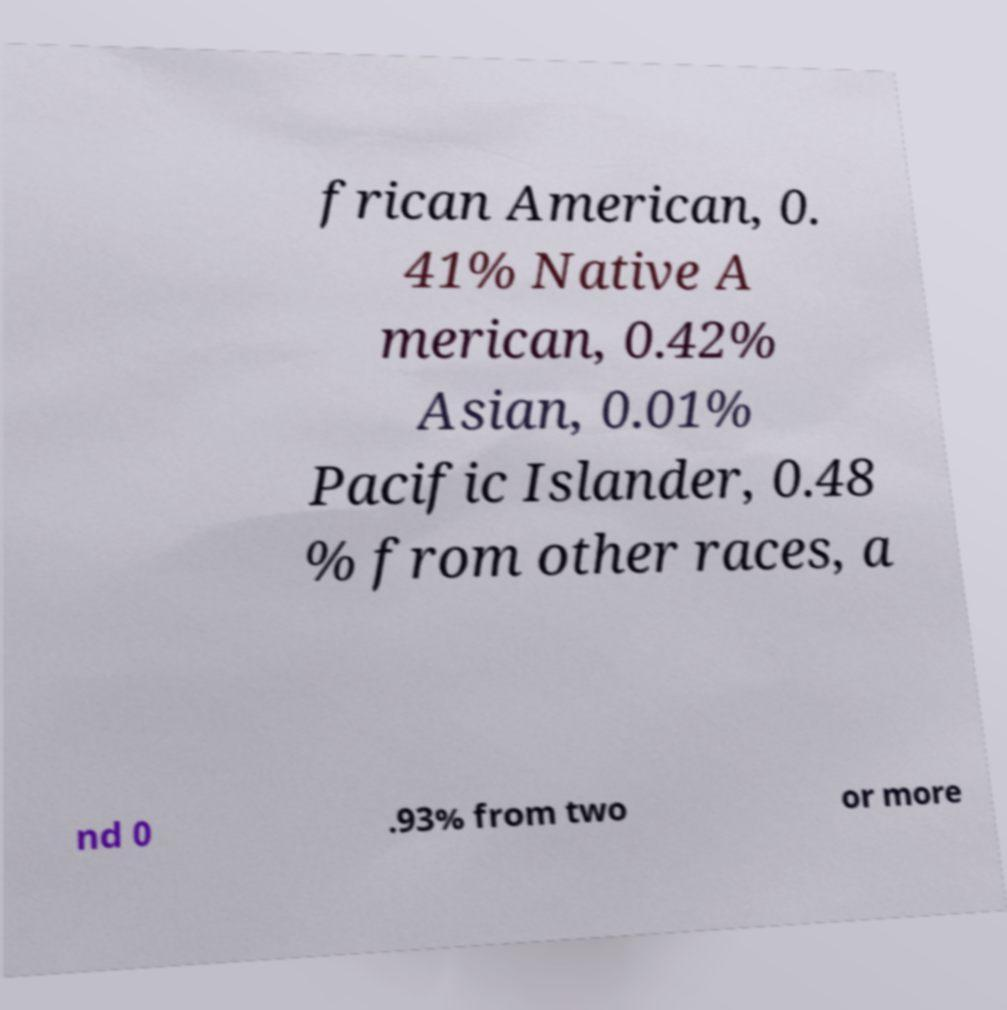Please identify and transcribe the text found in this image. frican American, 0. 41% Native A merican, 0.42% Asian, 0.01% Pacific Islander, 0.48 % from other races, a nd 0 .93% from two or more 